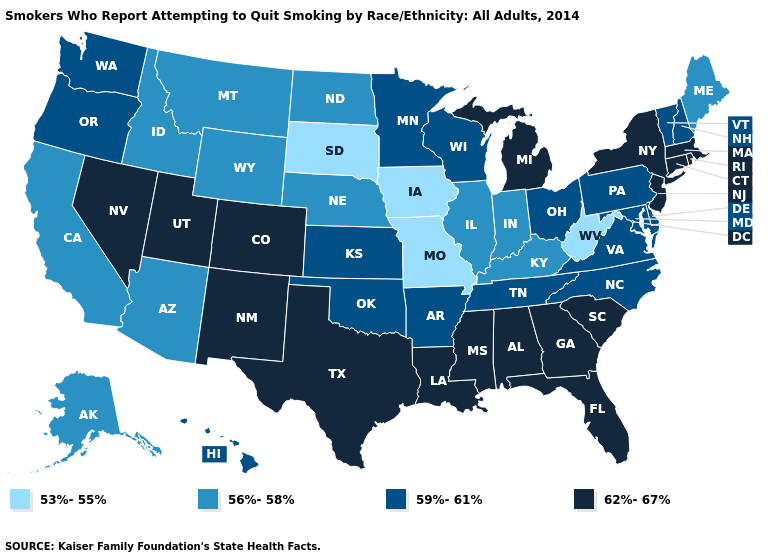Which states have the lowest value in the South?
Answer briefly. West Virginia. What is the value of Connecticut?
Quick response, please. 62%-67%. Name the states that have a value in the range 62%-67%?
Quick response, please. Alabama, Colorado, Connecticut, Florida, Georgia, Louisiana, Massachusetts, Michigan, Mississippi, Nevada, New Jersey, New Mexico, New York, Rhode Island, South Carolina, Texas, Utah. Does New Mexico have the highest value in the West?
Answer briefly. Yes. Which states have the lowest value in the USA?
Concise answer only. Iowa, Missouri, South Dakota, West Virginia. Which states hav the highest value in the Northeast?
Write a very short answer. Connecticut, Massachusetts, New Jersey, New York, Rhode Island. Which states have the lowest value in the USA?
Short answer required. Iowa, Missouri, South Dakota, West Virginia. What is the value of Alabama?
Short answer required. 62%-67%. What is the lowest value in the USA?
Be succinct. 53%-55%. Does Massachusetts have the same value as Texas?
Quick response, please. Yes. What is the value of Maryland?
Write a very short answer. 59%-61%. What is the value of West Virginia?
Be succinct. 53%-55%. What is the value of West Virginia?
Answer briefly. 53%-55%. What is the highest value in the USA?
Give a very brief answer. 62%-67%. What is the lowest value in the USA?
Write a very short answer. 53%-55%. 